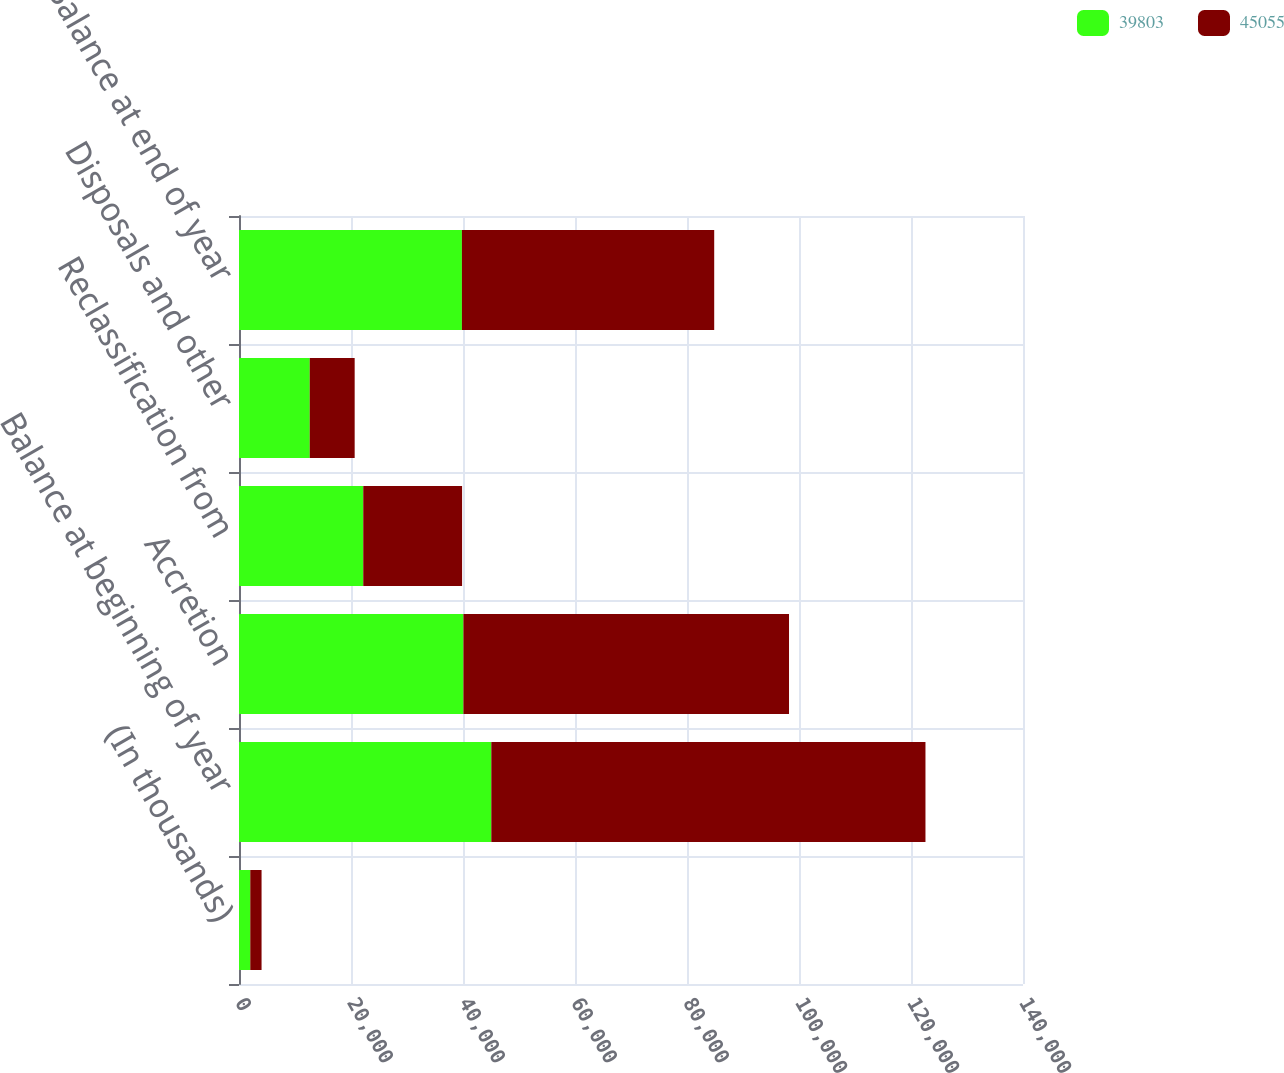Convert chart to OTSL. <chart><loc_0><loc_0><loc_500><loc_500><stacked_bar_chart><ecel><fcel>(In thousands)<fcel>Balance at beginning of year<fcel>Accretion<fcel>Reclassification from<fcel>Disposals and other<fcel>Balance at end of year<nl><fcel>39803<fcel>2015<fcel>45055<fcel>40077<fcel>22190<fcel>12635<fcel>39803<nl><fcel>45055<fcel>2014<fcel>77528<fcel>58140<fcel>17647<fcel>8020<fcel>45055<nl></chart> 